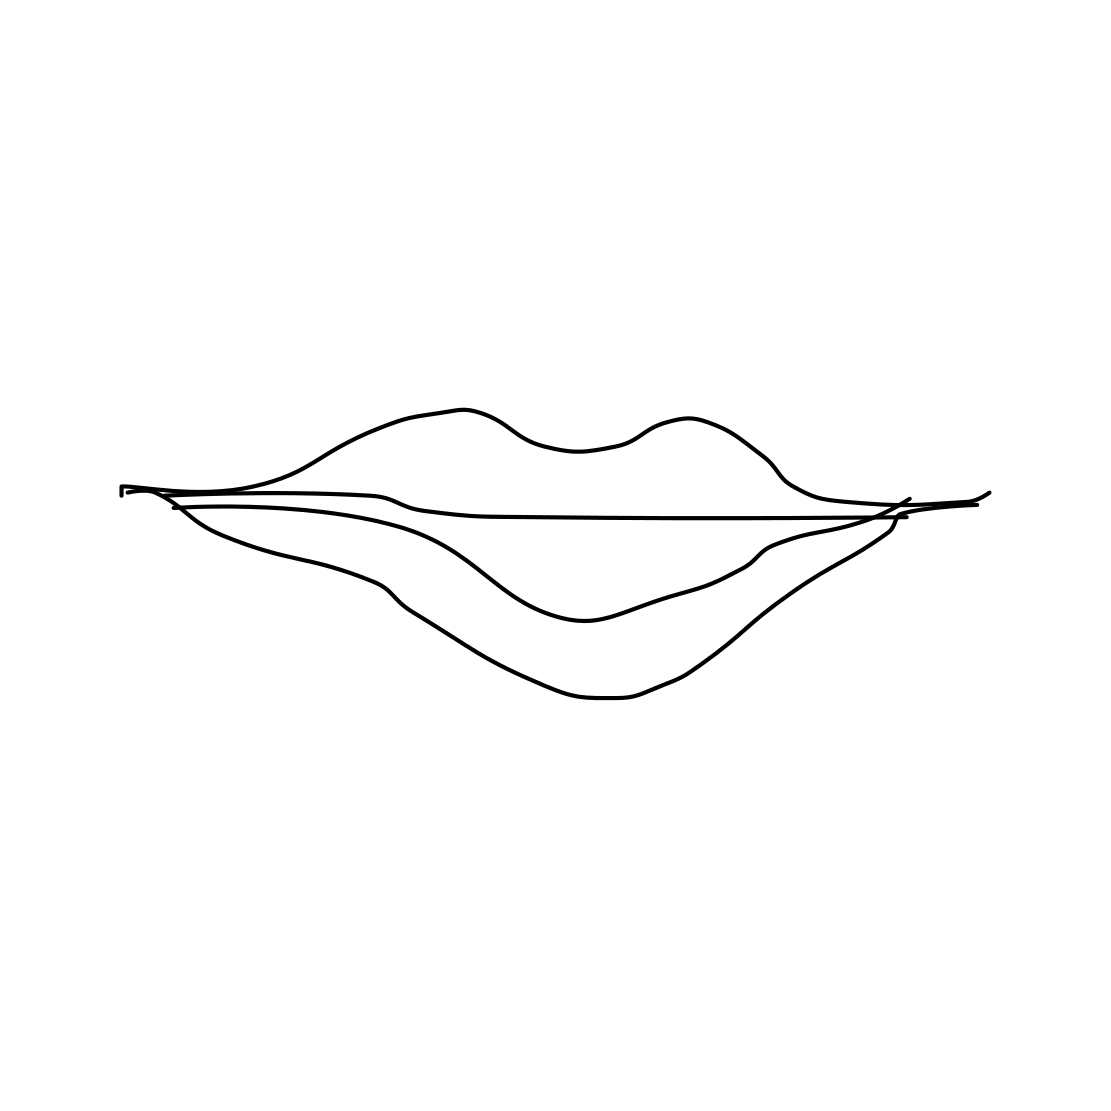What artistic style is represented in this image? The image depicts a pair of lips drawn in a minimalist and abstract style, emphasizing simplicity and form with minimal detail. Could this kind of image be used in any particular design field? Absolutely, it could be used in graphic design, particularly in branding for beauty products, or as an abstract element in various forms of modern art and fashion design. 